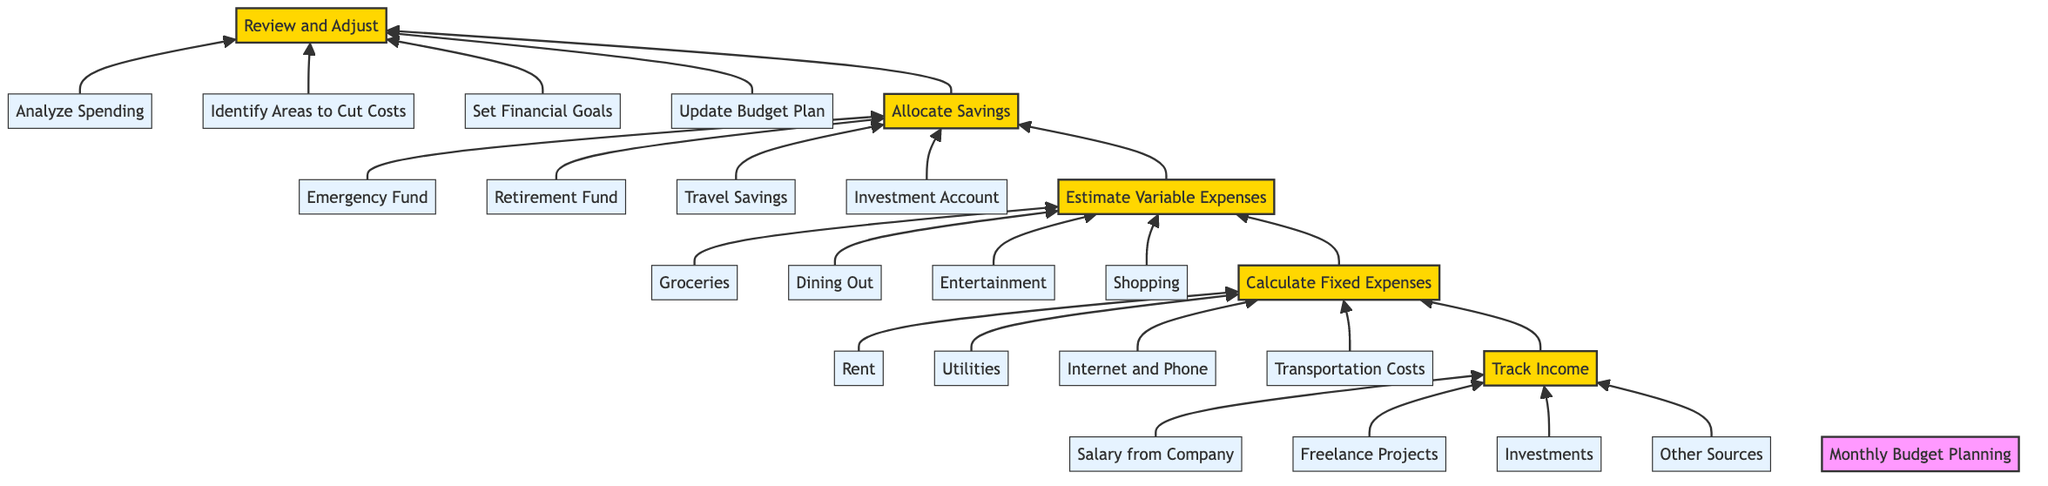What is the first step in the budget planning process? The diagram outlines the steps in monthly budget planning starting from the bottom. The first step listed is "Track Income."
Answer: Track Income How many details are provided under the "Estimate Variable Expenses" step? The "Estimate Variable Expenses" step has four specific details provided: Groceries, Dining Out, Entertainment, and Shopping. Therefore, there are four details.
Answer: 4 Which step is focused on analyzing spending? The step that includes analyzing spending is "Review and Adjust." It encompasses activities related to examining personal spending patterns.
Answer: Review and Adjust What are the four types of fixed expenses mentioned? The "Calculate Fixed Expenses" step breaks down into four specific types: Rent, Utilities, Internet and Phone, and Transportation Costs.
Answer: Rent, Utilities, Internet and Phone, Transportation Costs What is the last step in the monthly budget planning process? The last step listed at the top of the flow chart is "Review and Adjust," indicating it is the final action taken in the monthly budgeting process.
Answer: Review and Adjust How do the steps progress from bottom to top? The diagram shows a clear flow from bottom to top, starting with "Track Income," then moving to "Calculate Fixed Expenses," followed by "Estimate Variable Expenses," then "Allocate Savings," and finally culminating in "Review and Adjust." Thus, there is a logical progression through these steps.
Answer: From Track Income to Review and Adjust What is one of the categories to allocate savings? Under the "Allocate Savings" step, one category mentioned is "Emergency Fund," which is a common allocation in budget planning.
Answer: Emergency Fund 